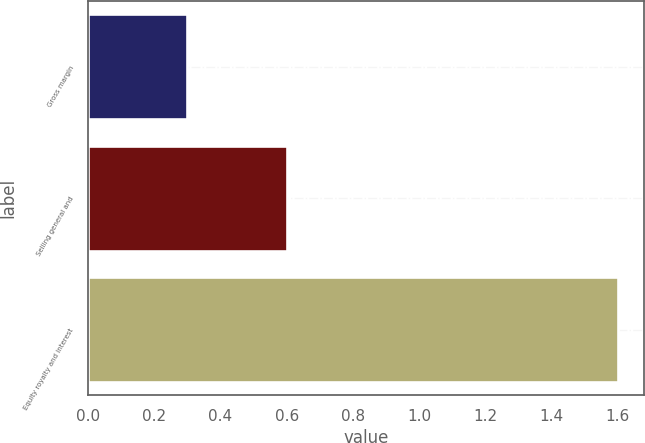Convert chart. <chart><loc_0><loc_0><loc_500><loc_500><bar_chart><fcel>Gross margin<fcel>Selling general and<fcel>Equity royalty and interest<nl><fcel>0.3<fcel>0.6<fcel>1.6<nl></chart> 